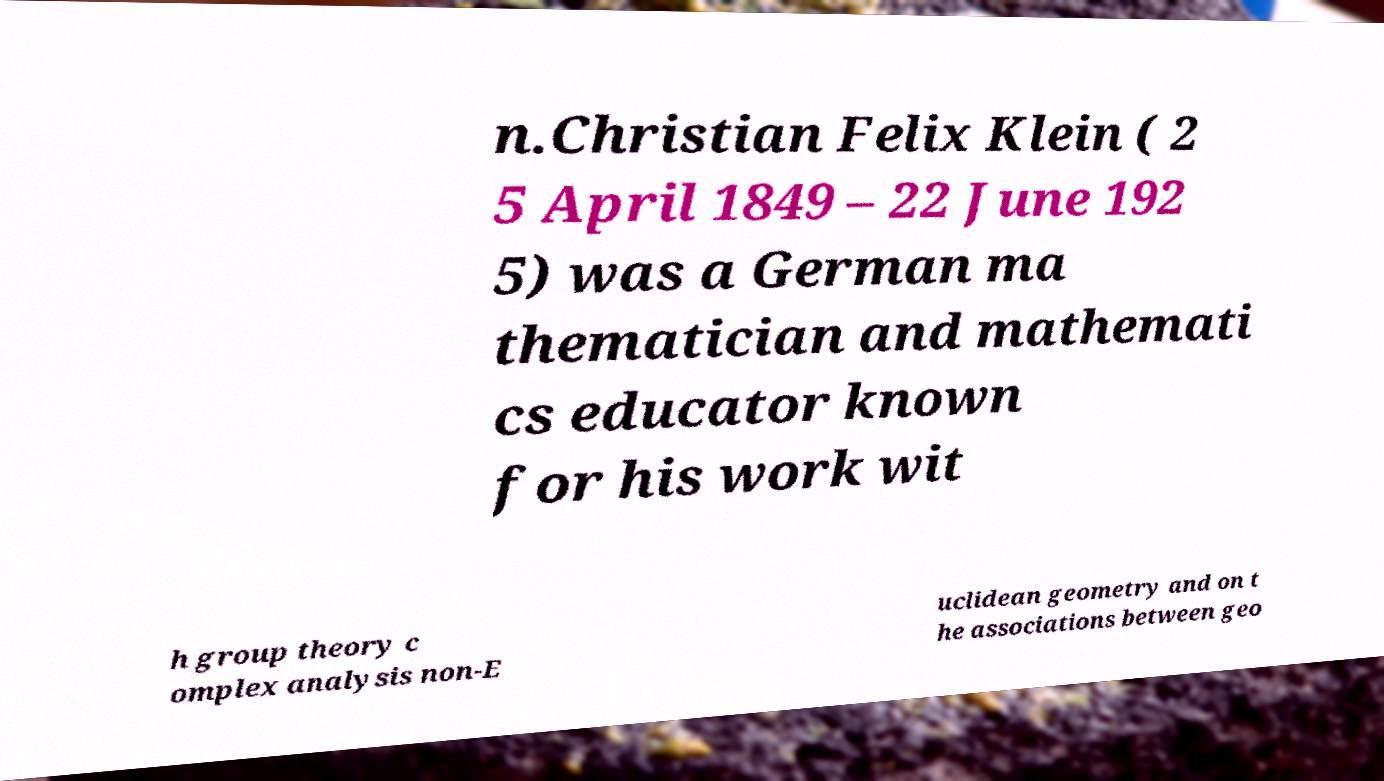Can you accurately transcribe the text from the provided image for me? n.Christian Felix Klein ( 2 5 April 1849 – 22 June 192 5) was a German ma thematician and mathemati cs educator known for his work wit h group theory c omplex analysis non-E uclidean geometry and on t he associations between geo 